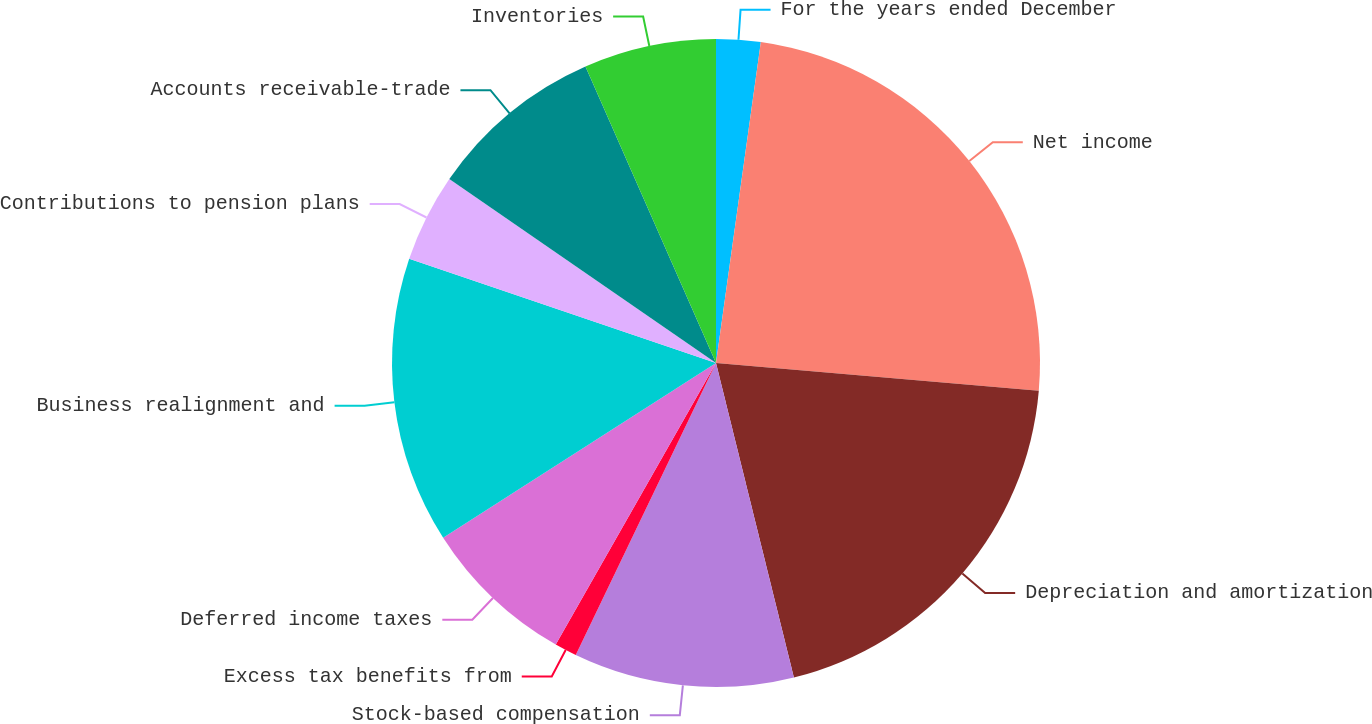Convert chart. <chart><loc_0><loc_0><loc_500><loc_500><pie_chart><fcel>For the years ended December<fcel>Net income<fcel>Depreciation and amortization<fcel>Stock-based compensation<fcel>Excess tax benefits from<fcel>Deferred income taxes<fcel>Business realignment and<fcel>Contributions to pension plans<fcel>Accounts receivable-trade<fcel>Inventories<nl><fcel>2.21%<fcel>24.16%<fcel>19.77%<fcel>10.99%<fcel>1.11%<fcel>7.7%<fcel>14.28%<fcel>4.4%<fcel>8.79%<fcel>6.6%<nl></chart> 